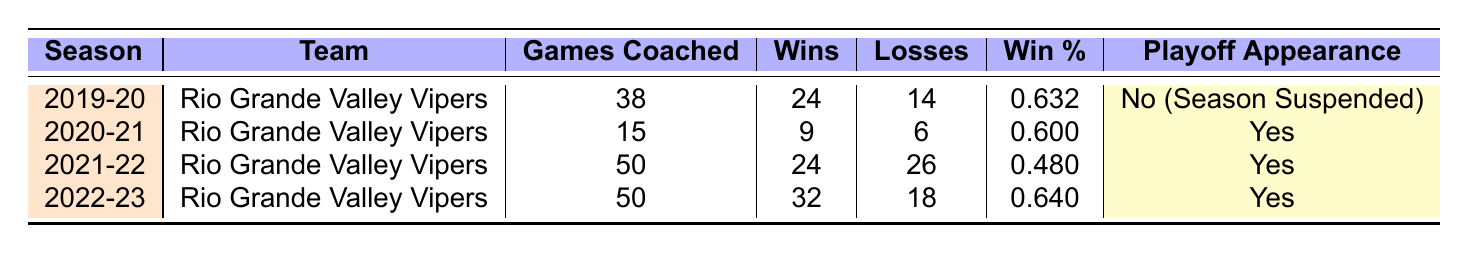What is the win percentage for the 2021-22 season? The win percentage for the 2021-22 season can be found in the "Win %" column for that season. It shows 0.480.
Answer: 0.480 How many games did Mahmoud Abdelfattah coach in total? To find the total number of games coached, sum the "Games Coached" values from all seasons: 38 + 15 + 50 + 50 = 153.
Answer: 153 In which season did the team achieve the highest number of wins? By looking at the "Wins" column, the 2022-23 season has the highest wins at 32.
Answer: 2022-23 Did the team make the playoffs in the 2019-20 season? The "Playoff Appearance" column for the 2019-20 season indicates "No (Season Suspended)", which means they did not make the playoffs.
Answer: No What is the average win percentage across all the seasons? To calculate the average win percentage, sum the win percentages: 0.632 + 0.600 + 0.480 + 0.640 = 2.352, then divide by 4 (the number of seasons), which equals 2.352 / 4 = 0.588.
Answer: 0.588 How many total losses did the team have across all seasons? To calculate total losses, sum the "Losses" values from each season: 14 + 6 + 26 + 18 = 64.
Answer: 64 Which season had the most games lost? The highest value in the "Losses" column is 26 for the 2021-22 season, which indicates it had the most games lost.
Answer: 2021-22 What proportion of seasons resulted in a playoff appearance? There are 4 total seasons, and 3 of them resulted in a playoff appearance: 2020-21, 2021-22, and 2022-23. Thus, the proportion is 3/4 or 75%.
Answer: 75% What is the difference in wins between the 2022-23 season and the 2021-22 season? For the 2022-23 season, there are 32 wins, and for the 2021-22 season, there are 24 wins. The difference is 32 - 24 = 8 wins.
Answer: 8 In which season did the team have a win percentage of 0.640? The "Win %" column shows that the 2022-23 season had a win percentage of 0.640.
Answer: 2022-23 